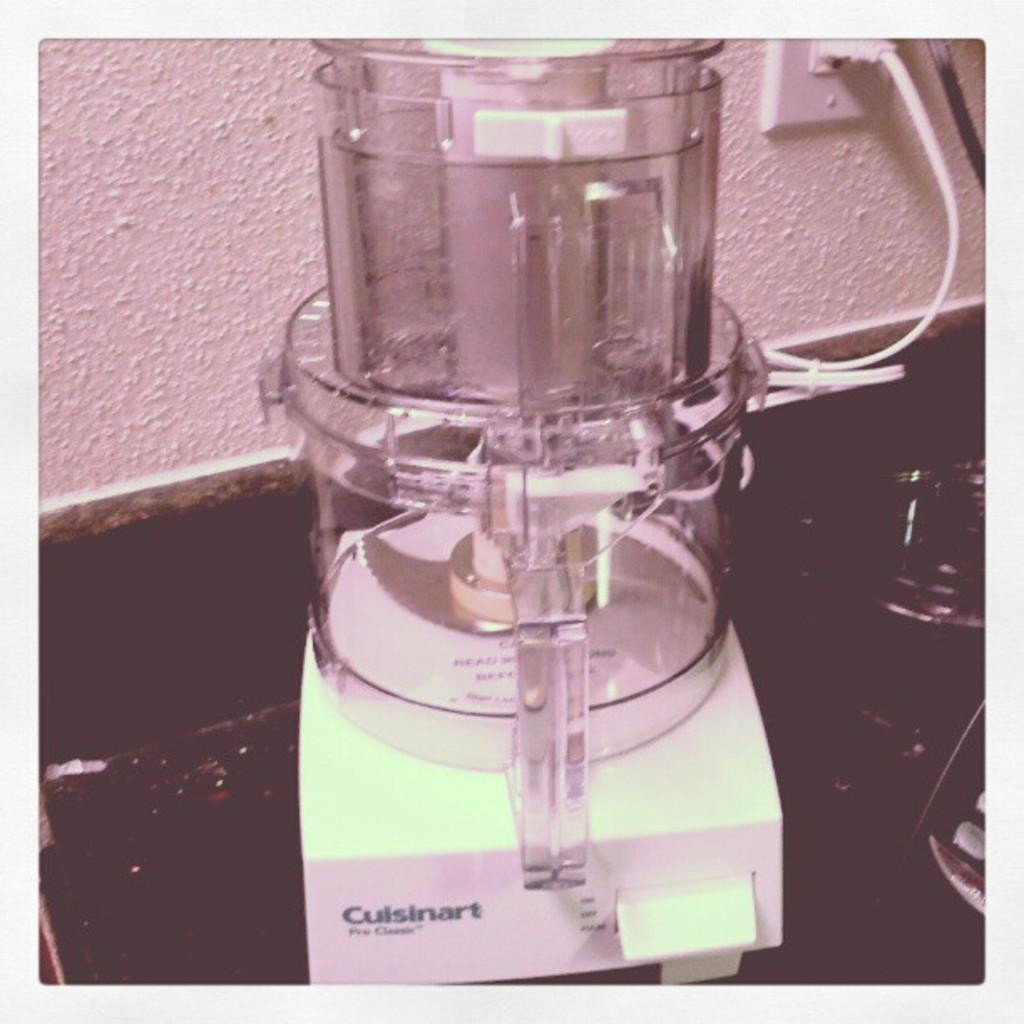<image>
Summarize the visual content of the image. A plugged in white Cuisinart sits on a very dark counter top. 